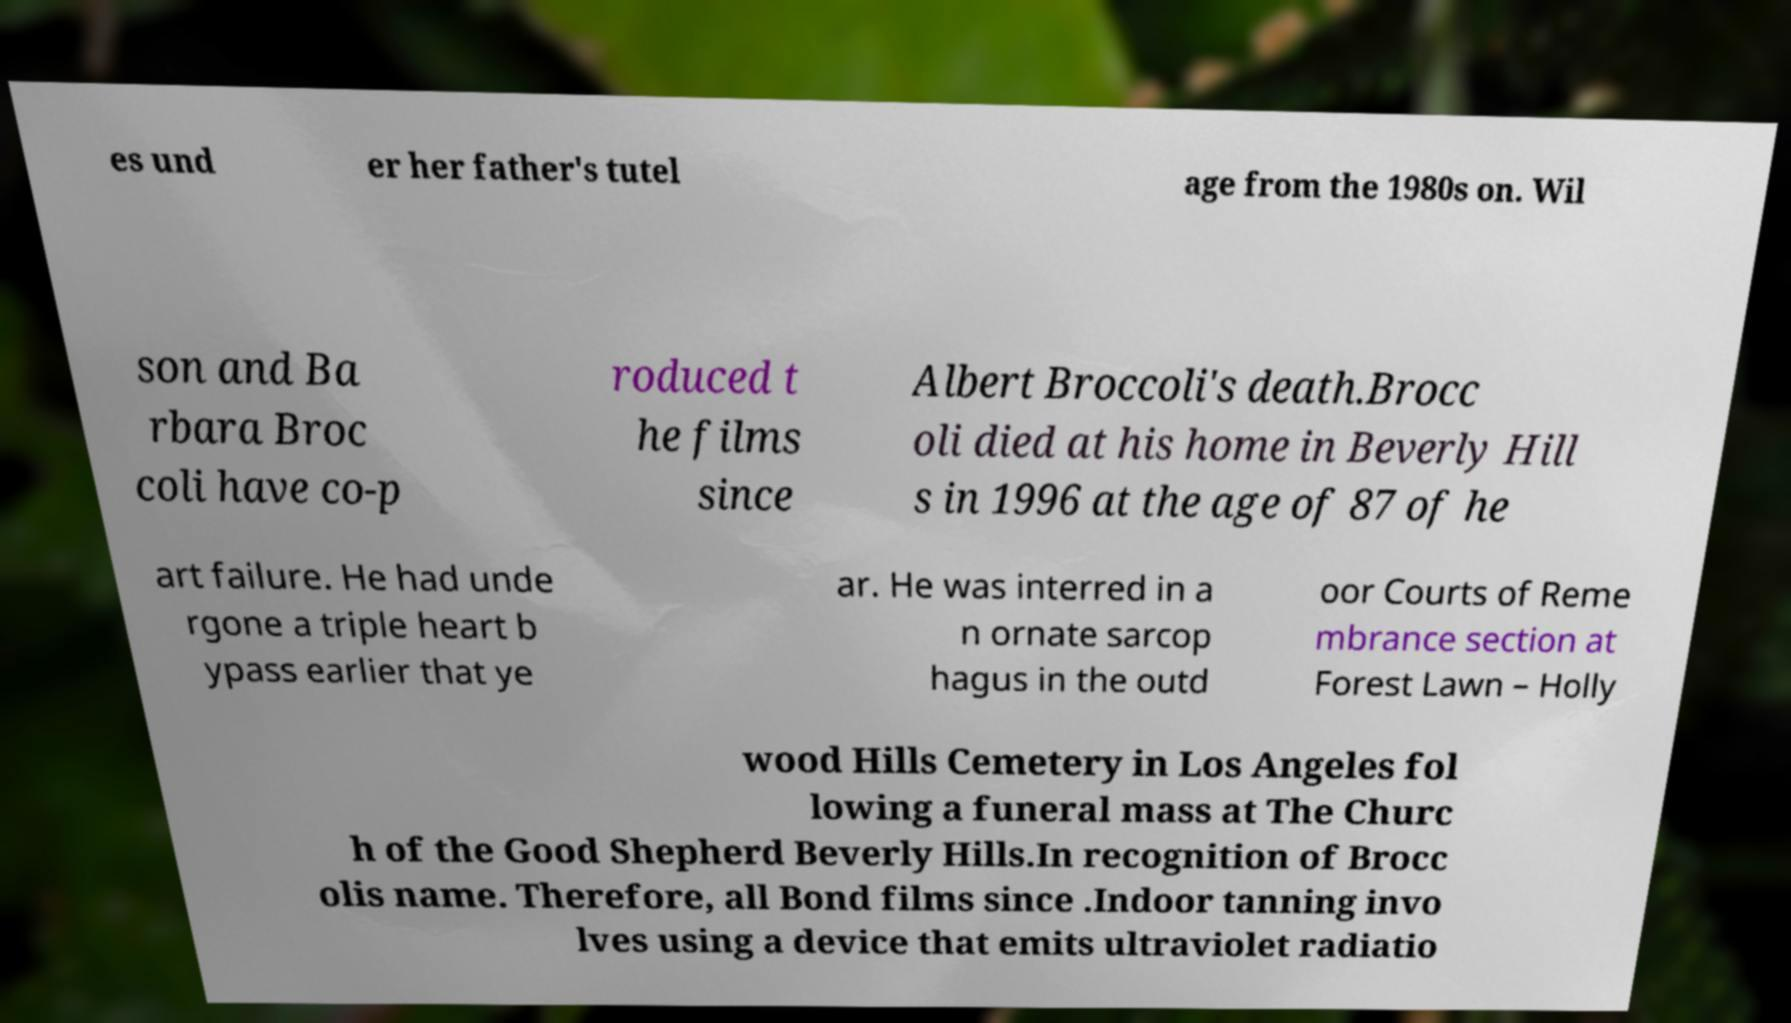Can you accurately transcribe the text from the provided image for me? es und er her father's tutel age from the 1980s on. Wil son and Ba rbara Broc coli have co-p roduced t he films since Albert Broccoli's death.Brocc oli died at his home in Beverly Hill s in 1996 at the age of 87 of he art failure. He had unde rgone a triple heart b ypass earlier that ye ar. He was interred in a n ornate sarcop hagus in the outd oor Courts of Reme mbrance section at Forest Lawn – Holly wood Hills Cemetery in Los Angeles fol lowing a funeral mass at The Churc h of the Good Shepherd Beverly Hills.In recognition of Brocc olis name. Therefore, all Bond films since .Indoor tanning invo lves using a device that emits ultraviolet radiatio 